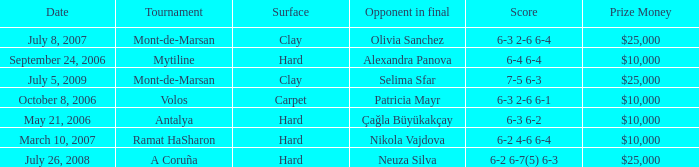Who was the opponent on carpet in a final? Patricia Mayr. 